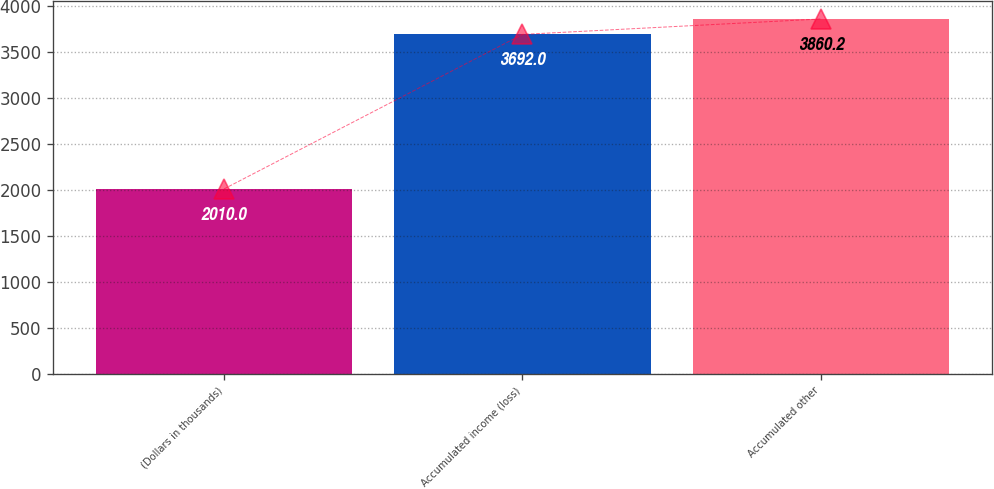<chart> <loc_0><loc_0><loc_500><loc_500><bar_chart><fcel>(Dollars in thousands)<fcel>Accumulated income (loss)<fcel>Accumulated other<nl><fcel>2010<fcel>3692<fcel>3860.2<nl></chart> 